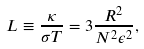<formula> <loc_0><loc_0><loc_500><loc_500>L \equiv \frac { \kappa } { \sigma T } = 3 \frac { R ^ { 2 } } { N ^ { 2 } \epsilon ^ { 2 } } ,</formula> 